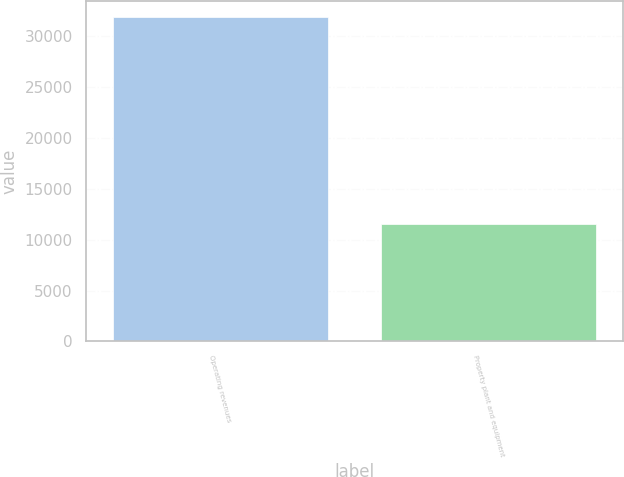<chart> <loc_0><loc_0><loc_500><loc_500><bar_chart><fcel>Operating revenues<fcel>Property plant and equipment<nl><fcel>31813<fcel>11490<nl></chart> 